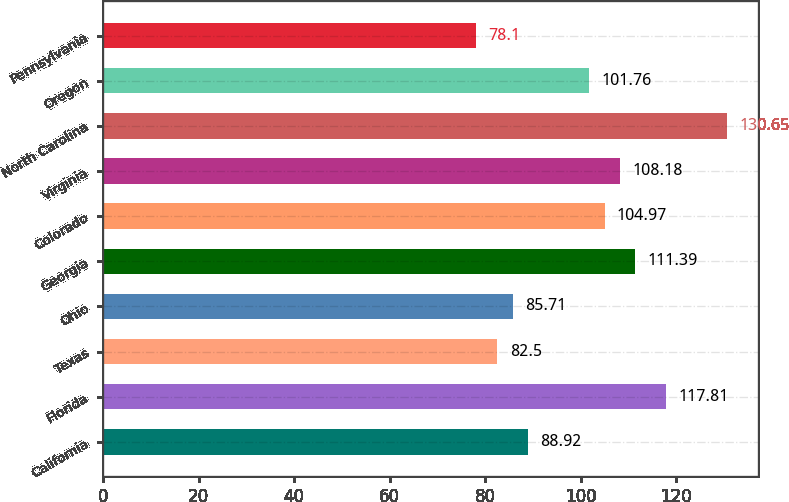<chart> <loc_0><loc_0><loc_500><loc_500><bar_chart><fcel>California<fcel>Florida<fcel>Texas<fcel>Ohio<fcel>Georgia<fcel>Colorado<fcel>Virginia<fcel>North Carolina<fcel>Oregon<fcel>Pennsylvania<nl><fcel>88.92<fcel>117.81<fcel>82.5<fcel>85.71<fcel>111.39<fcel>104.97<fcel>108.18<fcel>130.65<fcel>101.76<fcel>78.1<nl></chart> 